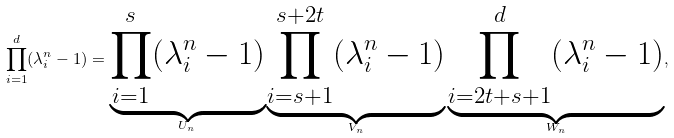Convert formula to latex. <formula><loc_0><loc_0><loc_500><loc_500>\prod _ { i = 1 } ^ { d } ( \lambda _ { i } ^ { n } - 1 ) = \underbrace { \prod _ { i = 1 } ^ { s } ( \lambda _ { i } ^ { n } - 1 ) } _ { U _ { n } } \underbrace { \prod _ { i = s + 1 } ^ { s + 2 t } ( \lambda _ { i } ^ { n } - 1 ) } _ { V _ { n } } \underbrace { \prod _ { i = 2 t + s + 1 } ^ { d } ( \lambda _ { i } ^ { n } - 1 ) } _ { W _ { n } } ,</formula> 